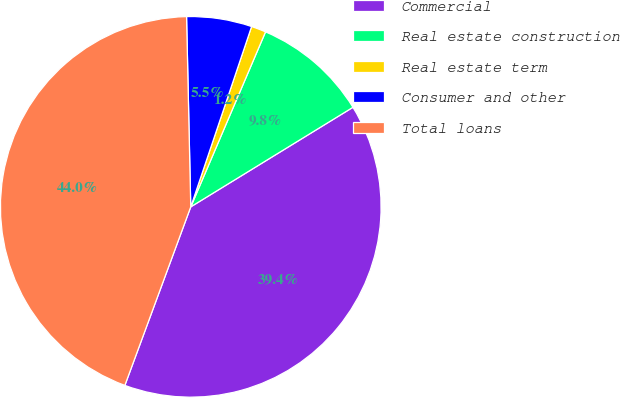Convert chart. <chart><loc_0><loc_0><loc_500><loc_500><pie_chart><fcel>Commercial<fcel>Real estate construction<fcel>Real estate term<fcel>Consumer and other<fcel>Total loans<nl><fcel>39.39%<fcel>9.81%<fcel>1.25%<fcel>5.53%<fcel>44.02%<nl></chart> 